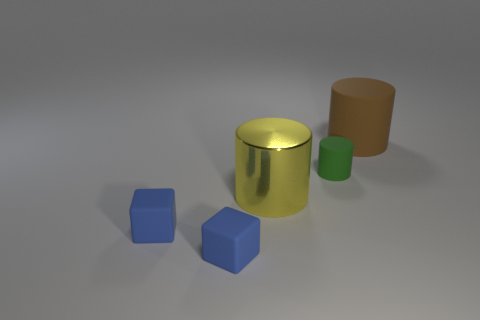Add 4 blue blocks. How many objects exist? 9 Subtract all blocks. How many objects are left? 3 Add 2 big yellow metallic things. How many big yellow metallic things exist? 3 Subtract 0 green blocks. How many objects are left? 5 Subtract all tiny blue shiny cubes. Subtract all brown matte cylinders. How many objects are left? 4 Add 1 rubber cylinders. How many rubber cylinders are left? 3 